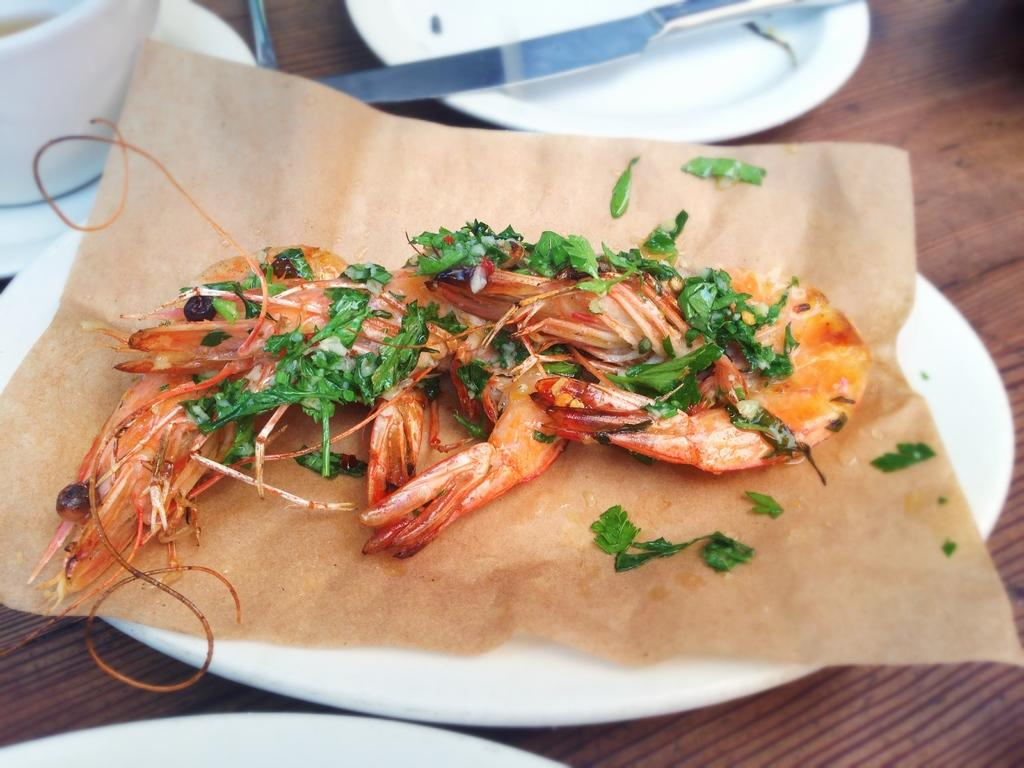What is the food item placed on in the image? There is a food item on the paper and another on the plate. What can be seen in the background of the image? There is a knife, plates, and a cup in the background. Where are all these items located? All of these items are on a table. Can you tell me how many teeth the food item on the plate has in the image? There are no teeth present on the food item or any other object in the image. 